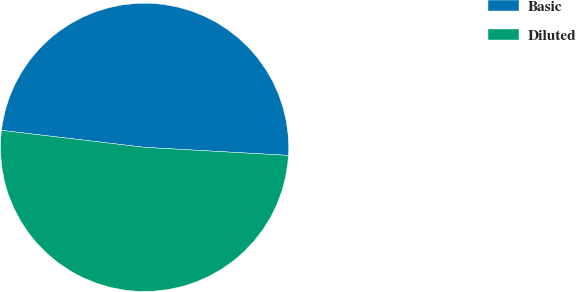<chart> <loc_0><loc_0><loc_500><loc_500><pie_chart><fcel>Basic<fcel>Diluted<nl><fcel>49.01%<fcel>50.99%<nl></chart> 